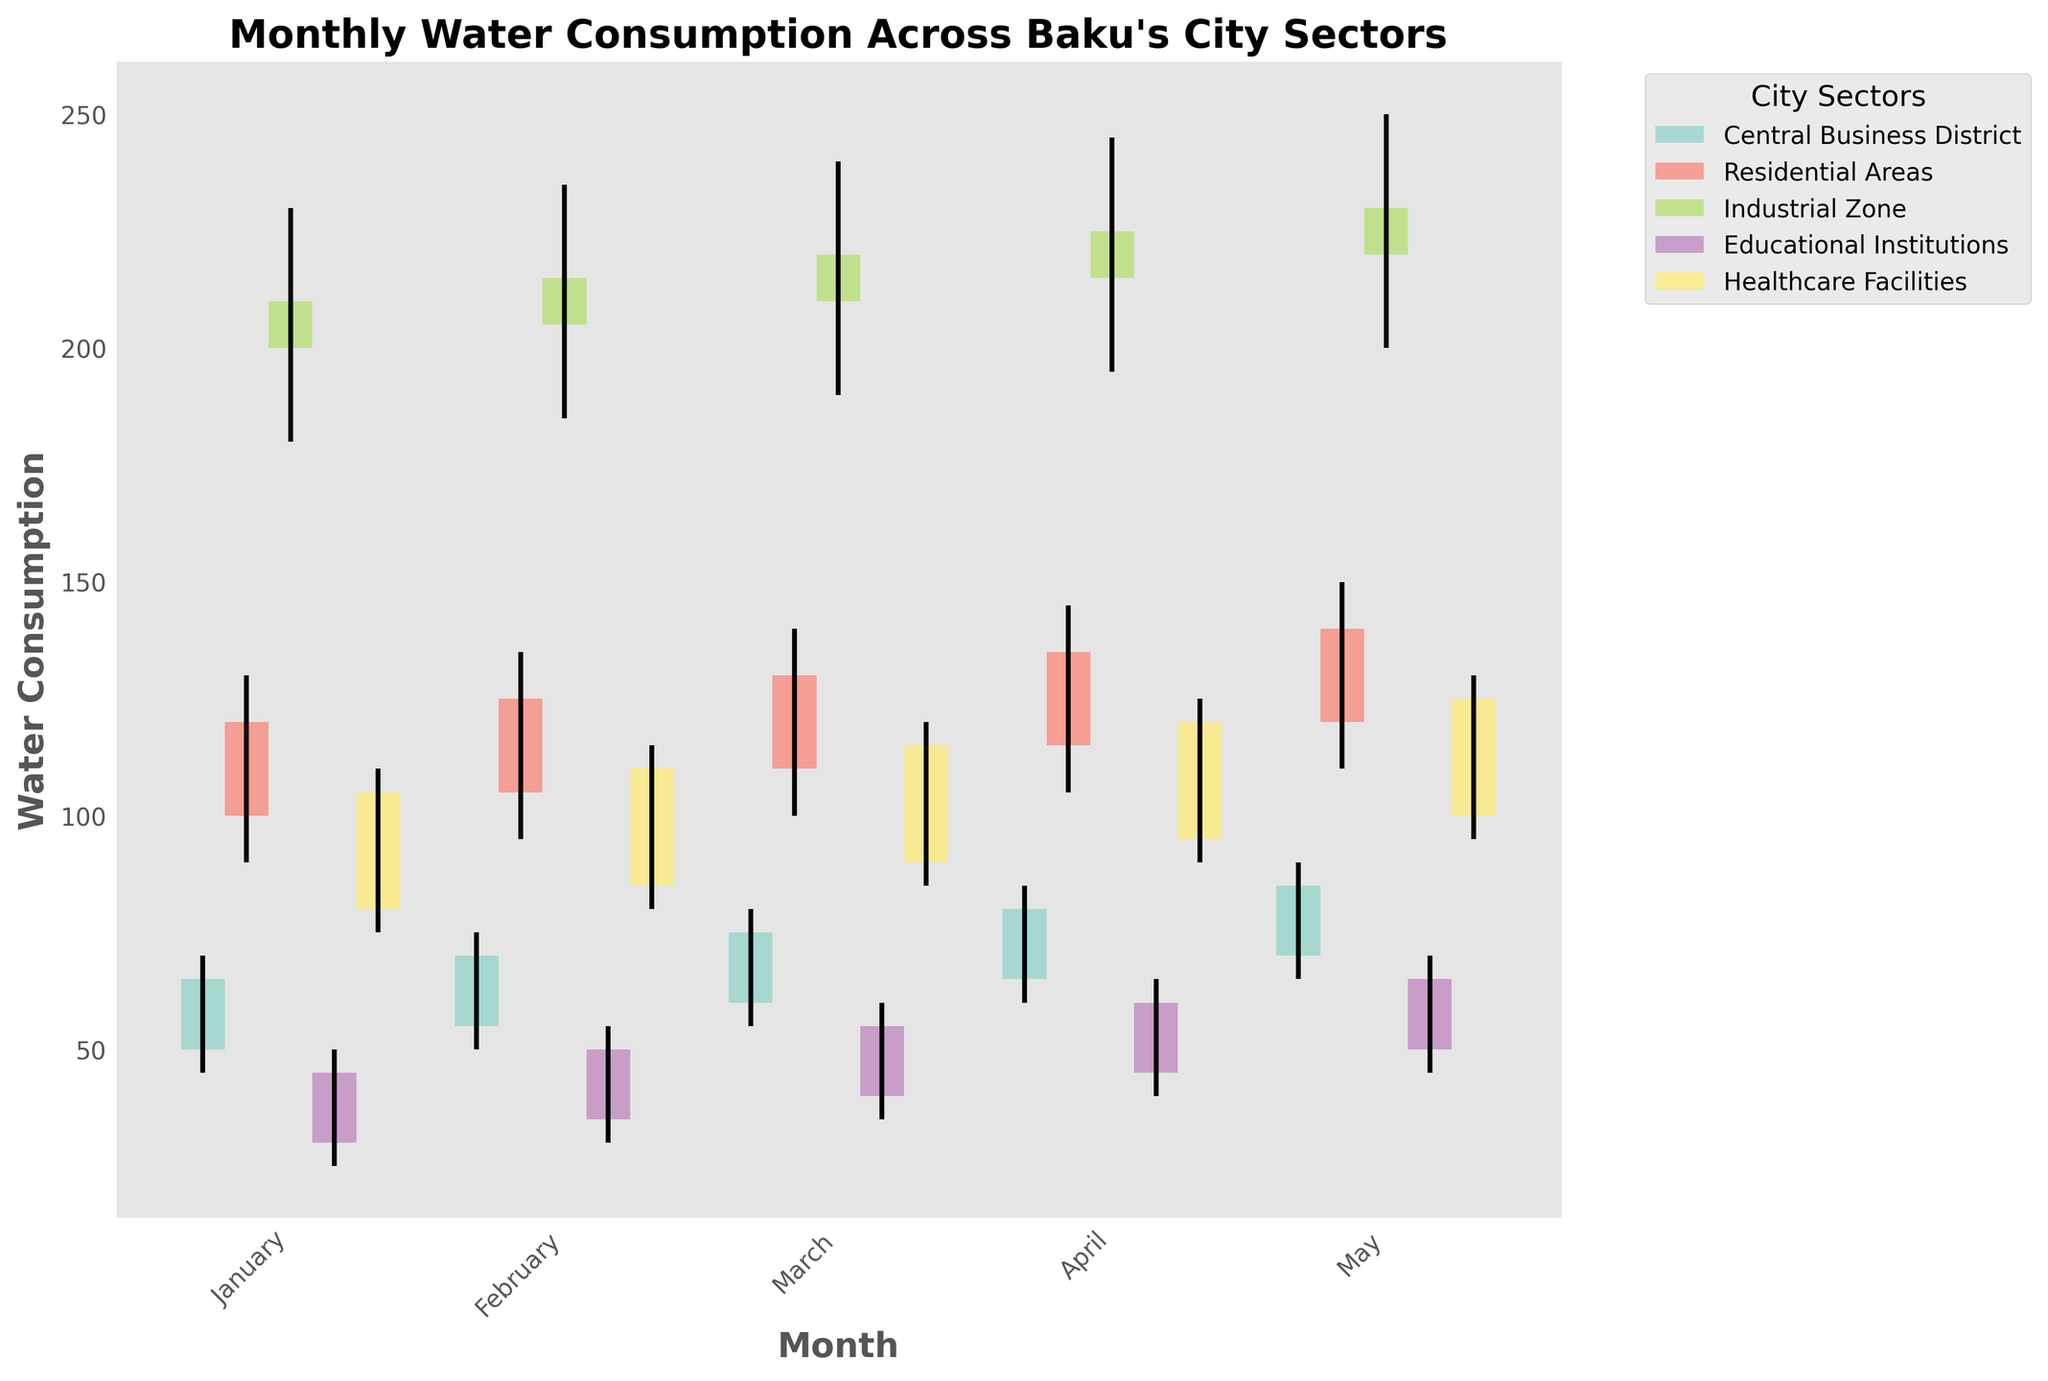What is the title of the figure? The title of the figure is displayed prominently at the top and reads "Monthly Water Consumption Across Baku's City Sectors."
Answer: Monthly Water Consumption Across Baku's City Sectors What does the x-axis represent? The x-axis is labeled "Month," and it represents the different months of the year for which data is plotted: January, February, March, April, May.
Answer: Month Which sector shows the highest water consumption in January? By looking at the height of the bars and the numerical values on them, the "Industrial Zone" sector shows the highest water consumption in January, with the high value being 230.
Answer: Industrial Zone How does the water consumption in Residential Areas compare between January and May? To compare, observe the top and bottom of the bars for these months in the "Residential Areas" section. In January, the range is from 90 to 130, while in May, the range is from 110 to 150. This indicates an overall increase in water consumption in Residential Areas from January to May.
Answer: Increased What is the average high value for the Central Business District across the months displayed? The high values for the Central Business District across January to May are 70, 75, 80, 85, and 90. Adding these gives 400. Dividing by the number of months (5) gives an average of 80.
Answer: 80 Across which months does the Healthcare Facilities sector show an increasing trend in the close values? The close values for Healthcare Facilities are 105, 110, 115, 120, and 125 for January to May, respectively. Checking the trend, all close values are increasing each month.
Answer: January to May Which sector has the most consistent water consumption (smallest range between the high and low values) over the months? To find this, observe the range (high minus low) for each sector over all months. "Educational Institutions" have values 50-25, 55-30, 60-35, 65-40, and 70-45. The ranges are all 25, making them the most consistent sector.
Answer: Educational Institutions What month shows the maximum close value in the Industrial Zone? Looking at the close values for the Industrial Zone across the months, the highest value is found in May with a value of 230.
Answer: May How much did the open value change from January to May in the Healthcare Facilities sector? For the Healthcare Facilities sector, the open value in January is 80 and in May it is 100. The change is calculated as 100 - 80, which is 20.
Answer: 20 Comparing March data, which sector had the largest range between the high and low values? In March, the ranges (high minus low) for all sectors are: Central Business District (25), Residential Areas (40), Industrial Zone (50), Educational Institutions (25), Healthcare Facilities (35). The largest range is 50, found in the Industrial Zone.
Answer: Industrial Zone 